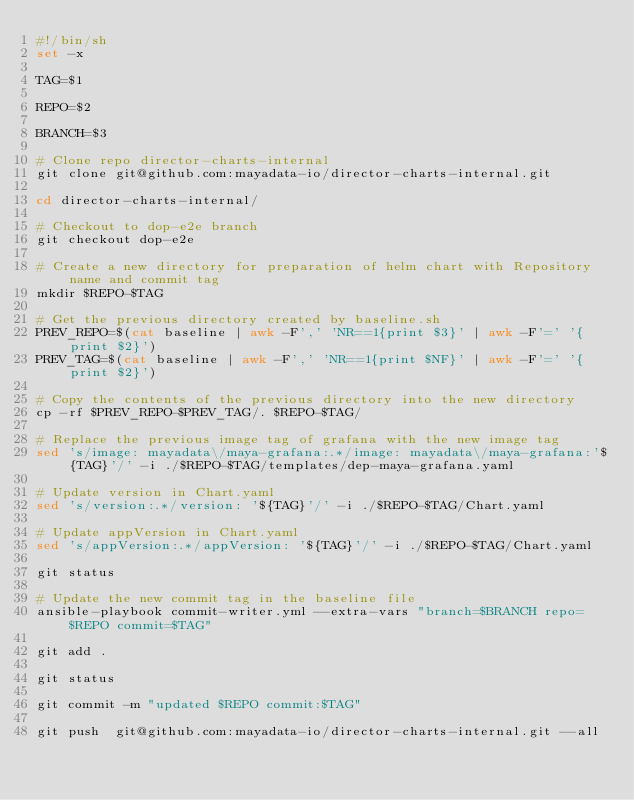Convert code to text. <code><loc_0><loc_0><loc_500><loc_500><_Bash_>#!/bin/sh
set -x

TAG=$1

REPO=$2

BRANCH=$3

# Clone repo director-charts-internal
git clone git@github.com:mayadata-io/director-charts-internal.git

cd director-charts-internal/

# Checkout to dop-e2e branch
git checkout dop-e2e

# Create a new directory for preparation of helm chart with Repository name and commit tag
mkdir $REPO-$TAG

# Get the previous directory created by baseline.sh
PREV_REPO=$(cat baseline | awk -F',' 'NR==1{print $3}' | awk -F'=' '{print $2}')
PREV_TAG=$(cat baseline | awk -F',' 'NR==1{print $NF}' | awk -F'=' '{print $2}')

# Copy the contents of the previous directory into the new directory
cp -rf $PREV_REPO-$PREV_TAG/. $REPO-$TAG/

# Replace the previous image tag of grafana with the new image tag
sed 's/image: mayadata\/maya-grafana:.*/image: mayadata\/maya-grafana:'${TAG}'/' -i ./$REPO-$TAG/templates/dep-maya-grafana.yaml

# Update version in Chart.yaml
sed 's/version:.*/version: '${TAG}'/' -i ./$REPO-$TAG/Chart.yaml

# Update appVersion in Chart.yaml
sed 's/appVersion:.*/appVersion: '${TAG}'/' -i ./$REPO-$TAG/Chart.yaml

git status 

# Update the new commit tag in the baseline file 
ansible-playbook commit-writer.yml --extra-vars "branch=$BRANCH repo=$REPO commit=$TAG"

git add .

git status

git commit -m "updated $REPO commit:$TAG"

git push  git@github.com:mayadata-io/director-charts-internal.git --all
</code> 